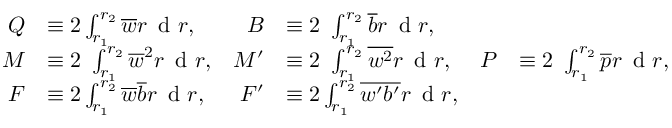<formula> <loc_0><loc_0><loc_500><loc_500>\begin{array} { r l r l r l } { Q } & { \equiv 2 \int _ { r _ { 1 } } ^ { r _ { 2 } } \overline { w } r \, d r , } & { B } & { \equiv 2 \ \int _ { r _ { 1 } } ^ { r _ { 2 } } \overline { b } r \, d r , } & \\ { M } & { \equiv 2 \ \int _ { r _ { 1 } } ^ { r _ { 2 } } \overline { w } ^ { 2 } r \, d r , } & { M ^ { \prime } } & { \equiv 2 \ \int _ { r _ { 1 } } ^ { r _ { 2 } } \overline { { w ^ { 2 } } } r \, d r , } & { P } & { \equiv 2 \ \int _ { r _ { 1 } } ^ { r _ { 2 } } \overline { p } r \, d r , } \\ { F } & { \equiv 2 \int _ { r _ { 1 } } ^ { r _ { 2 } } \overline { w } \overline { b } r \, d r , } & { F ^ { \prime } } & { \equiv 2 \int _ { r _ { 1 } } ^ { r _ { 2 } } \overline { { w ^ { \prime } b ^ { \prime } } } r \, d r , } & \end{array}</formula> 